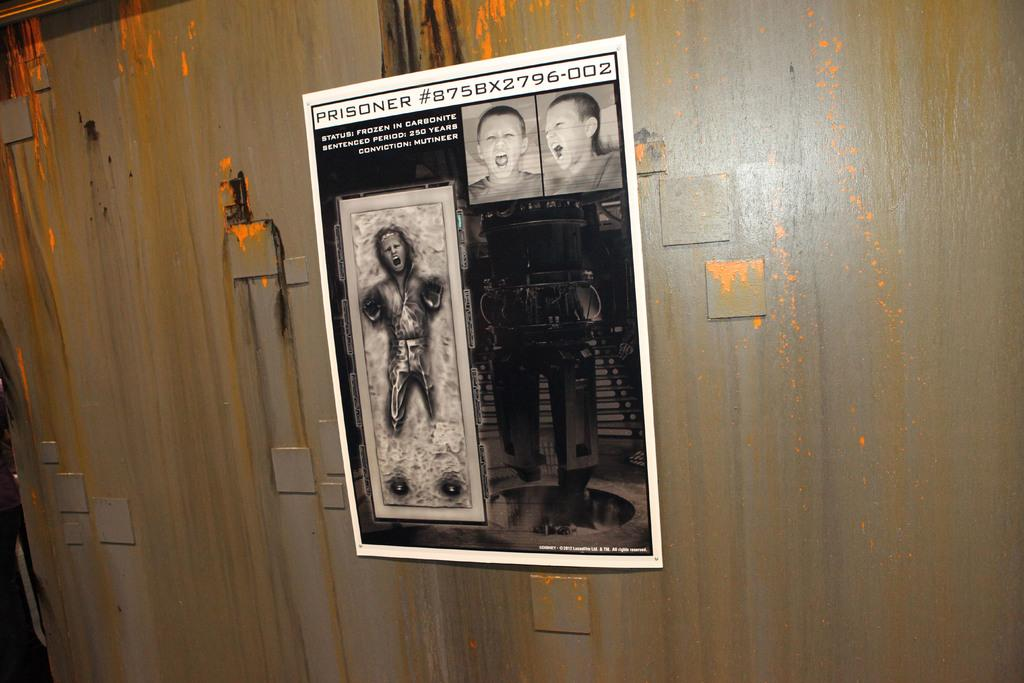Provide a one-sentence caption for the provided image. A poster illustrating two faces of boys screaming and a skeletal looking man screaming with the words at the top saying PRISIONER #875BX2796-002. 